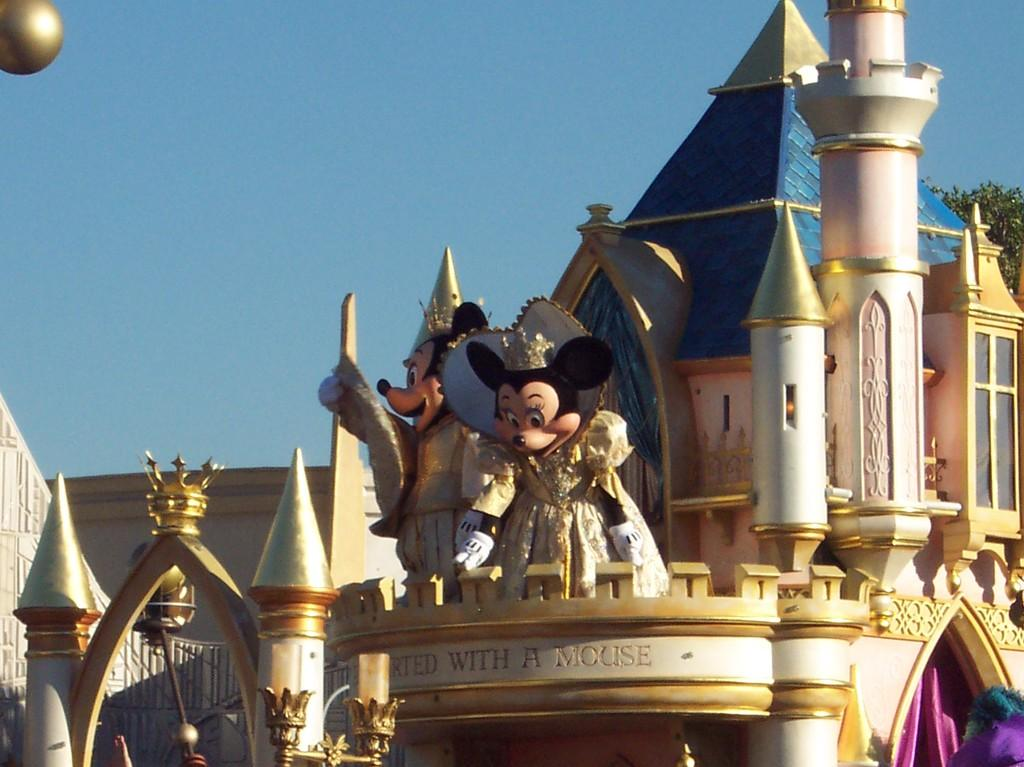What type of structure is visible in the image? There is a building in the image. What other objects can be seen in the image? There are cloth items and statues in the image. What type of natural elements are present in the image? Leaves are present in the image. What can be seen in the background of the image? The sky is visible in the background of the image. What type of pancake is being served at the event in the image? There is no event or pancake present in the image. 